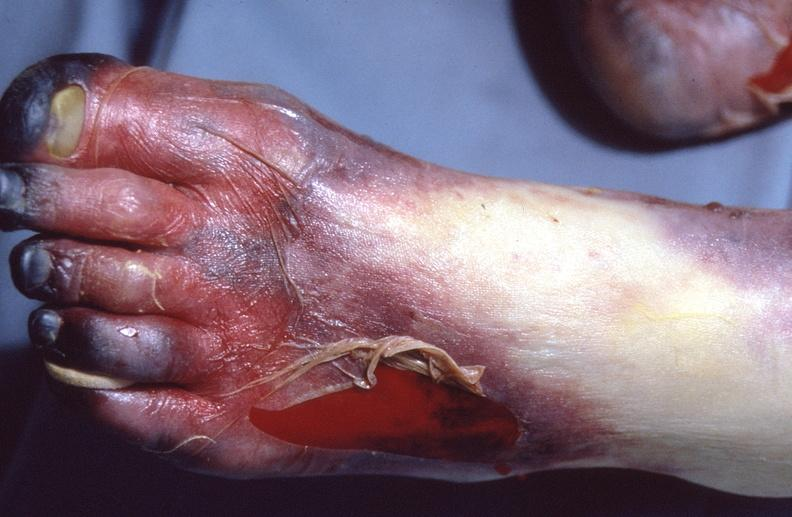why does this image show skin ulceration and necrosis, disseminated intravascular coagulation?
Answer the question using a single word or phrase. Due to acetaminophen toxicity 